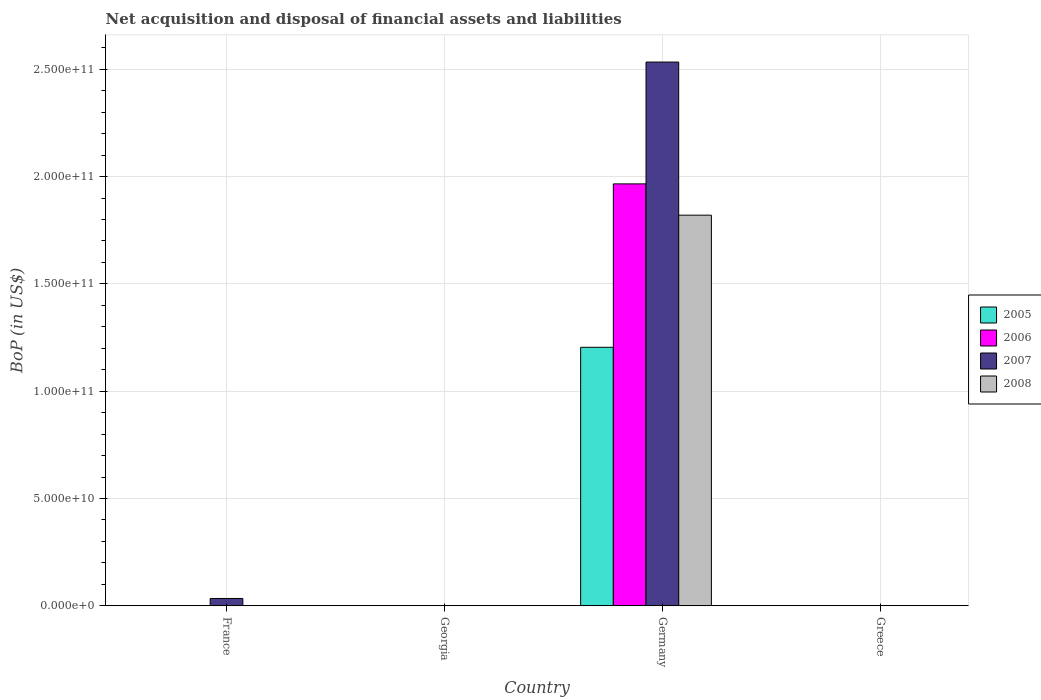How many different coloured bars are there?
Keep it short and to the point. 4. How many bars are there on the 1st tick from the left?
Provide a succinct answer. 1. How many bars are there on the 4th tick from the right?
Give a very brief answer. 1. In how many cases, is the number of bars for a given country not equal to the number of legend labels?
Your response must be concise. 3. What is the Balance of Payments in 2005 in Greece?
Offer a terse response. 0. Across all countries, what is the maximum Balance of Payments in 2008?
Keep it short and to the point. 1.82e+11. What is the total Balance of Payments in 2006 in the graph?
Keep it short and to the point. 1.97e+11. What is the difference between the Balance of Payments in 2006 in Germany and the Balance of Payments in 2008 in Georgia?
Make the answer very short. 1.97e+11. What is the average Balance of Payments in 2005 per country?
Ensure brevity in your answer.  3.01e+1. What is the difference between the Balance of Payments of/in 2005 and Balance of Payments of/in 2008 in Germany?
Your answer should be compact. -6.16e+1. In how many countries, is the Balance of Payments in 2005 greater than 240000000000 US$?
Offer a very short reply. 0. What is the difference between the highest and the lowest Balance of Payments in 2008?
Give a very brief answer. 1.82e+11. Is it the case that in every country, the sum of the Balance of Payments in 2007 and Balance of Payments in 2008 is greater than the sum of Balance of Payments in 2006 and Balance of Payments in 2005?
Ensure brevity in your answer.  No. How many bars are there?
Give a very brief answer. 5. Are all the bars in the graph horizontal?
Keep it short and to the point. No. How many countries are there in the graph?
Offer a terse response. 4. Are the values on the major ticks of Y-axis written in scientific E-notation?
Provide a succinct answer. Yes. Does the graph contain grids?
Offer a very short reply. Yes. How are the legend labels stacked?
Ensure brevity in your answer.  Vertical. What is the title of the graph?
Offer a terse response. Net acquisition and disposal of financial assets and liabilities. Does "1969" appear as one of the legend labels in the graph?
Offer a terse response. No. What is the label or title of the X-axis?
Offer a very short reply. Country. What is the label or title of the Y-axis?
Your answer should be very brief. BoP (in US$). What is the BoP (in US$) of 2005 in France?
Ensure brevity in your answer.  0. What is the BoP (in US$) in 2006 in France?
Provide a short and direct response. 0. What is the BoP (in US$) of 2007 in France?
Keep it short and to the point. 3.41e+09. What is the BoP (in US$) in 2005 in Georgia?
Give a very brief answer. 0. What is the BoP (in US$) of 2006 in Georgia?
Your response must be concise. 0. What is the BoP (in US$) of 2007 in Georgia?
Your answer should be compact. 0. What is the BoP (in US$) of 2008 in Georgia?
Provide a short and direct response. 0. What is the BoP (in US$) of 2005 in Germany?
Your answer should be very brief. 1.20e+11. What is the BoP (in US$) in 2006 in Germany?
Your response must be concise. 1.97e+11. What is the BoP (in US$) in 2007 in Germany?
Give a very brief answer. 2.53e+11. What is the BoP (in US$) in 2008 in Germany?
Give a very brief answer. 1.82e+11. What is the BoP (in US$) in 2006 in Greece?
Give a very brief answer. 0. Across all countries, what is the maximum BoP (in US$) in 2005?
Keep it short and to the point. 1.20e+11. Across all countries, what is the maximum BoP (in US$) of 2006?
Provide a succinct answer. 1.97e+11. Across all countries, what is the maximum BoP (in US$) in 2007?
Your response must be concise. 2.53e+11. Across all countries, what is the maximum BoP (in US$) of 2008?
Your answer should be compact. 1.82e+11. Across all countries, what is the minimum BoP (in US$) of 2007?
Provide a succinct answer. 0. Across all countries, what is the minimum BoP (in US$) of 2008?
Your answer should be compact. 0. What is the total BoP (in US$) of 2005 in the graph?
Provide a succinct answer. 1.20e+11. What is the total BoP (in US$) in 2006 in the graph?
Your answer should be very brief. 1.97e+11. What is the total BoP (in US$) in 2007 in the graph?
Give a very brief answer. 2.57e+11. What is the total BoP (in US$) in 2008 in the graph?
Your answer should be very brief. 1.82e+11. What is the difference between the BoP (in US$) in 2007 in France and that in Germany?
Keep it short and to the point. -2.50e+11. What is the difference between the BoP (in US$) of 2007 in France and the BoP (in US$) of 2008 in Germany?
Provide a succinct answer. -1.79e+11. What is the average BoP (in US$) in 2005 per country?
Offer a very short reply. 3.01e+1. What is the average BoP (in US$) of 2006 per country?
Provide a short and direct response. 4.92e+1. What is the average BoP (in US$) in 2007 per country?
Provide a short and direct response. 6.42e+1. What is the average BoP (in US$) in 2008 per country?
Provide a short and direct response. 4.55e+1. What is the difference between the BoP (in US$) in 2005 and BoP (in US$) in 2006 in Germany?
Keep it short and to the point. -7.62e+1. What is the difference between the BoP (in US$) of 2005 and BoP (in US$) of 2007 in Germany?
Give a very brief answer. -1.33e+11. What is the difference between the BoP (in US$) of 2005 and BoP (in US$) of 2008 in Germany?
Offer a very short reply. -6.16e+1. What is the difference between the BoP (in US$) in 2006 and BoP (in US$) in 2007 in Germany?
Give a very brief answer. -5.68e+1. What is the difference between the BoP (in US$) of 2006 and BoP (in US$) of 2008 in Germany?
Your answer should be compact. 1.46e+1. What is the difference between the BoP (in US$) in 2007 and BoP (in US$) in 2008 in Germany?
Offer a terse response. 7.13e+1. What is the ratio of the BoP (in US$) in 2007 in France to that in Germany?
Give a very brief answer. 0.01. What is the difference between the highest and the lowest BoP (in US$) of 2005?
Give a very brief answer. 1.20e+11. What is the difference between the highest and the lowest BoP (in US$) of 2006?
Ensure brevity in your answer.  1.97e+11. What is the difference between the highest and the lowest BoP (in US$) of 2007?
Your answer should be compact. 2.53e+11. What is the difference between the highest and the lowest BoP (in US$) of 2008?
Provide a succinct answer. 1.82e+11. 